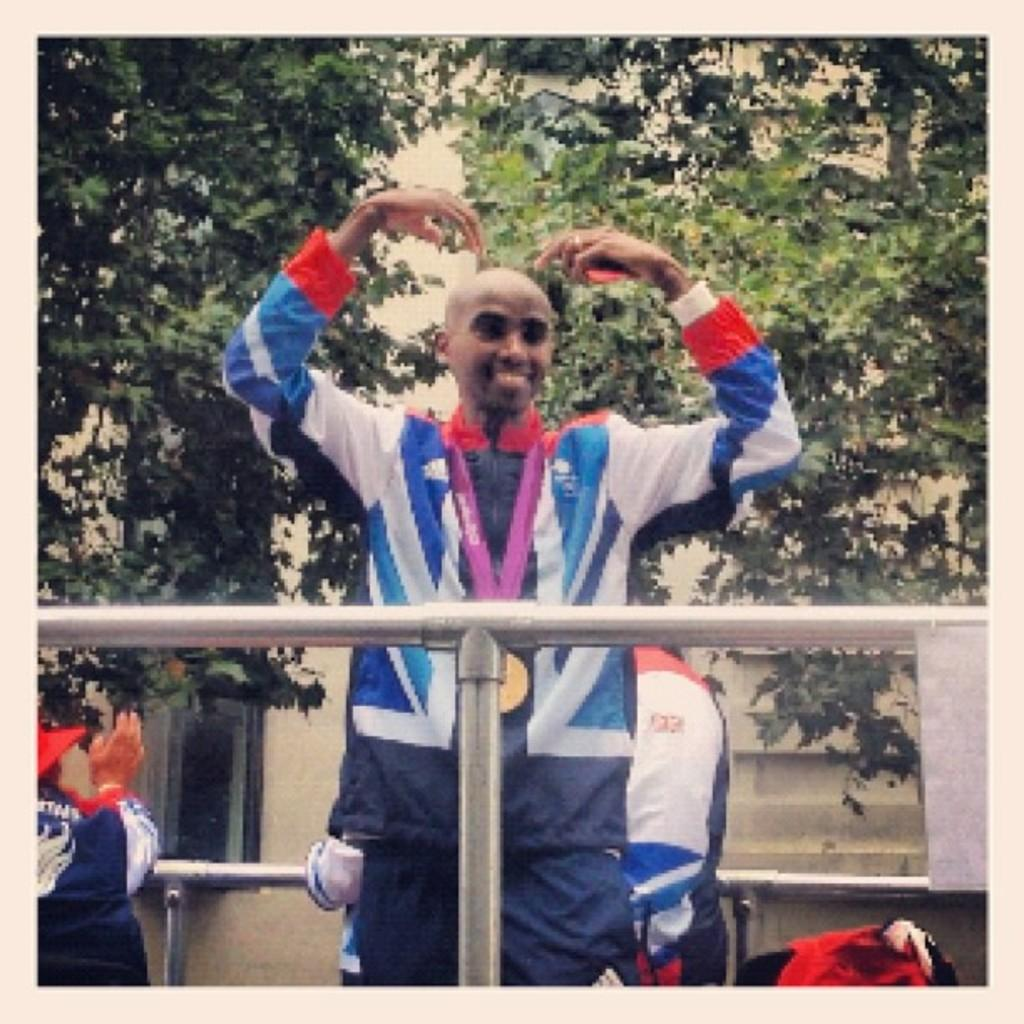What can be seen in the image involving people? There are people standing in the image. What type of structures are present in the image? There are metal poles and a wall in the image. What type of natural elements can be seen in the image? There are trees in the image. What type of cart is being used by the people in the image? There is no cart present in the image; it only features people, metal poles, a wall, and trees. 